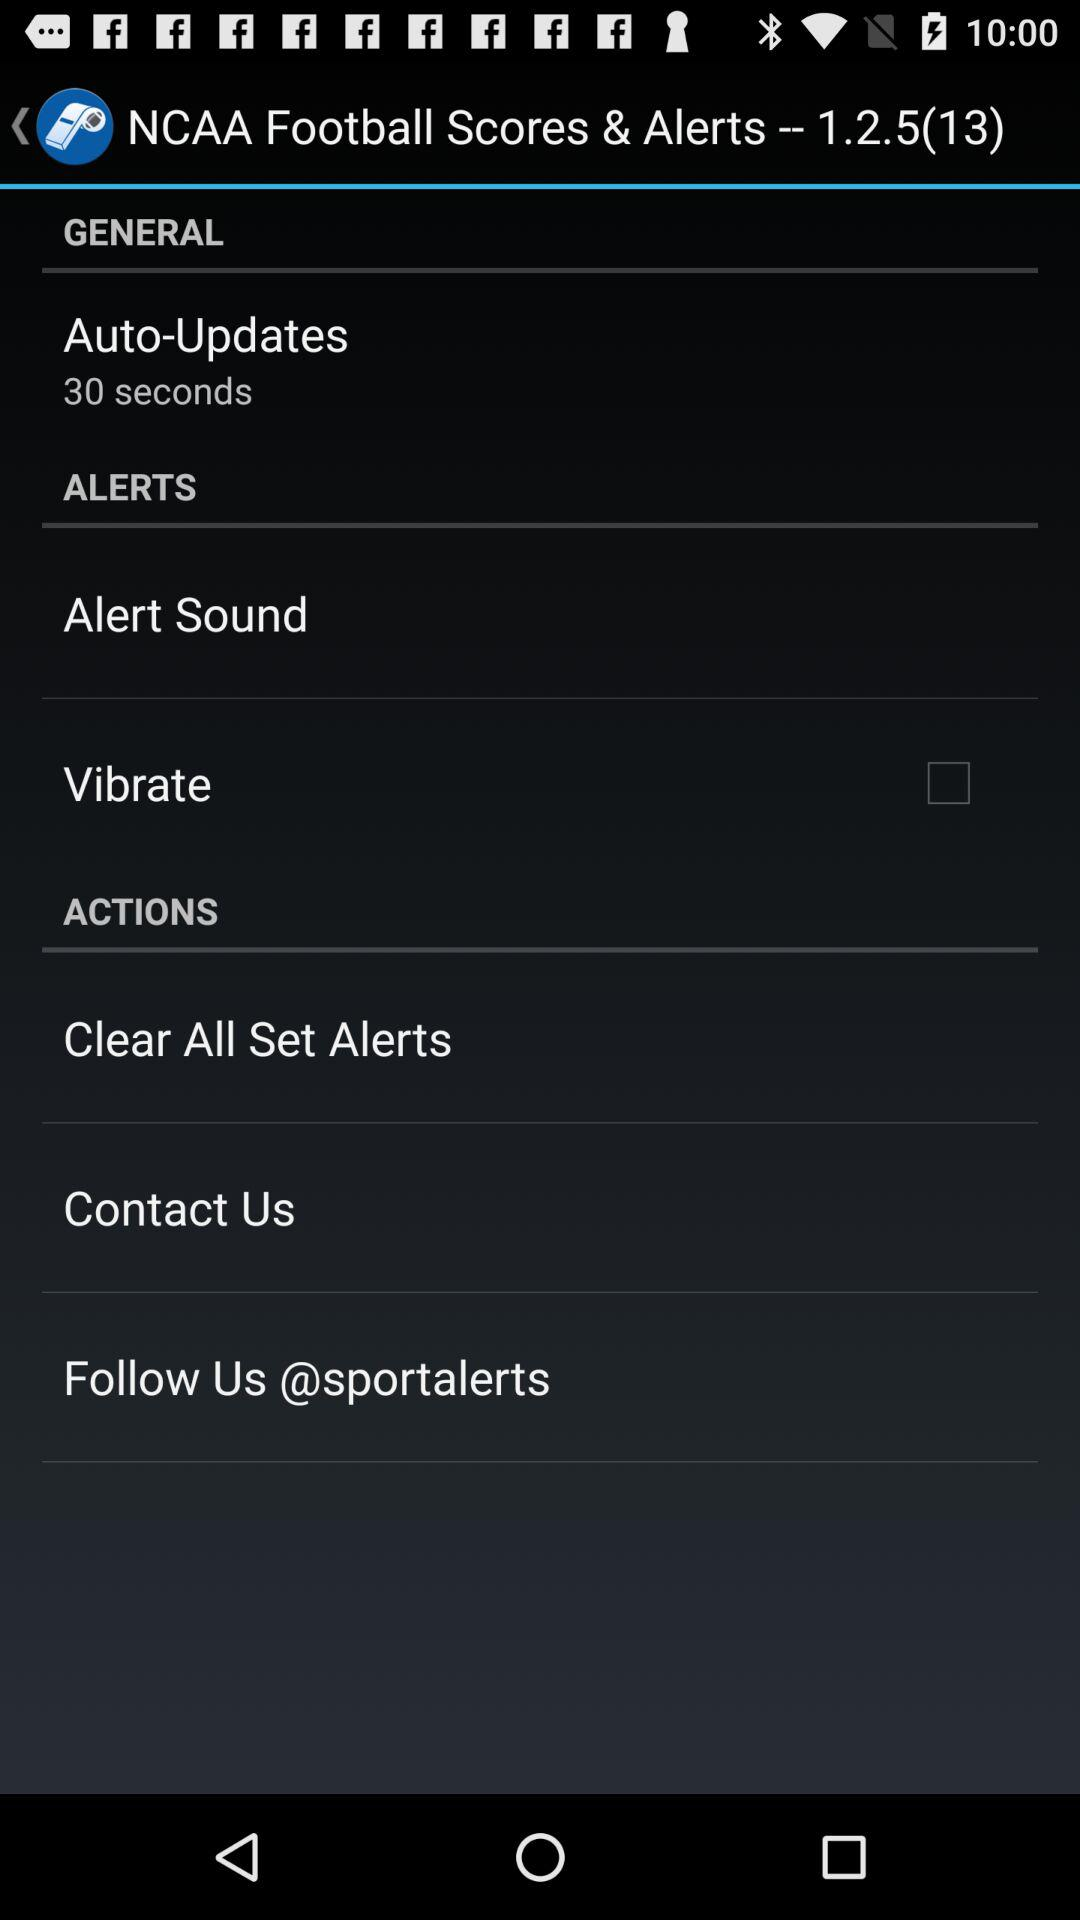How to clear all the set alters?
When the provided information is insufficient, respond with <no answer>. <no answer> 